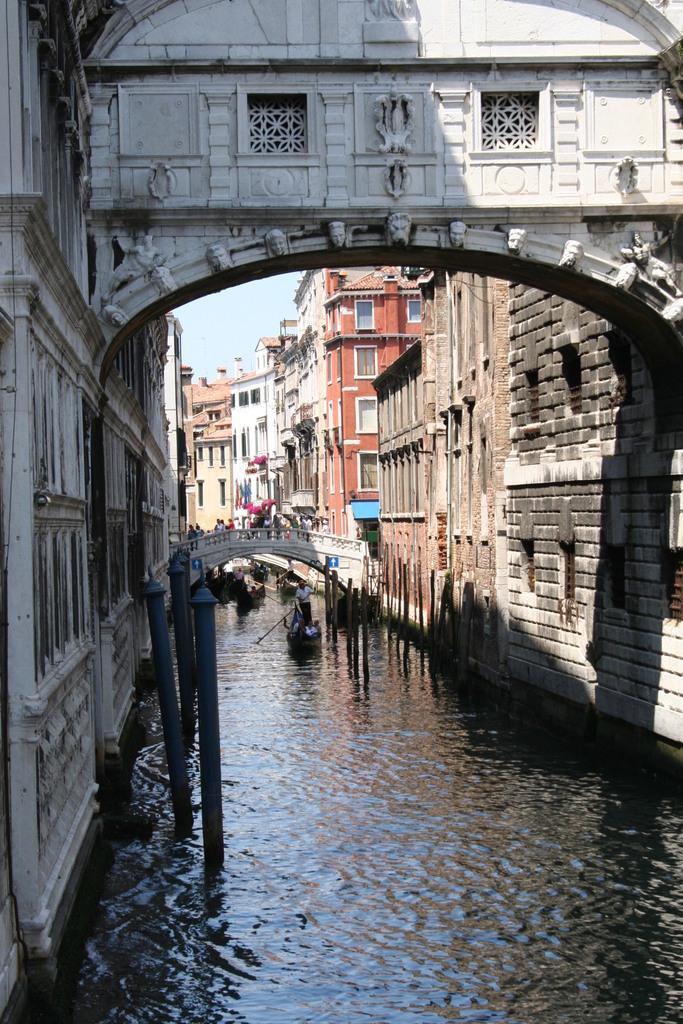Please provide a concise description of this image. In the picture I can see the lake in which some boats are moving, around we can see some buildings. 